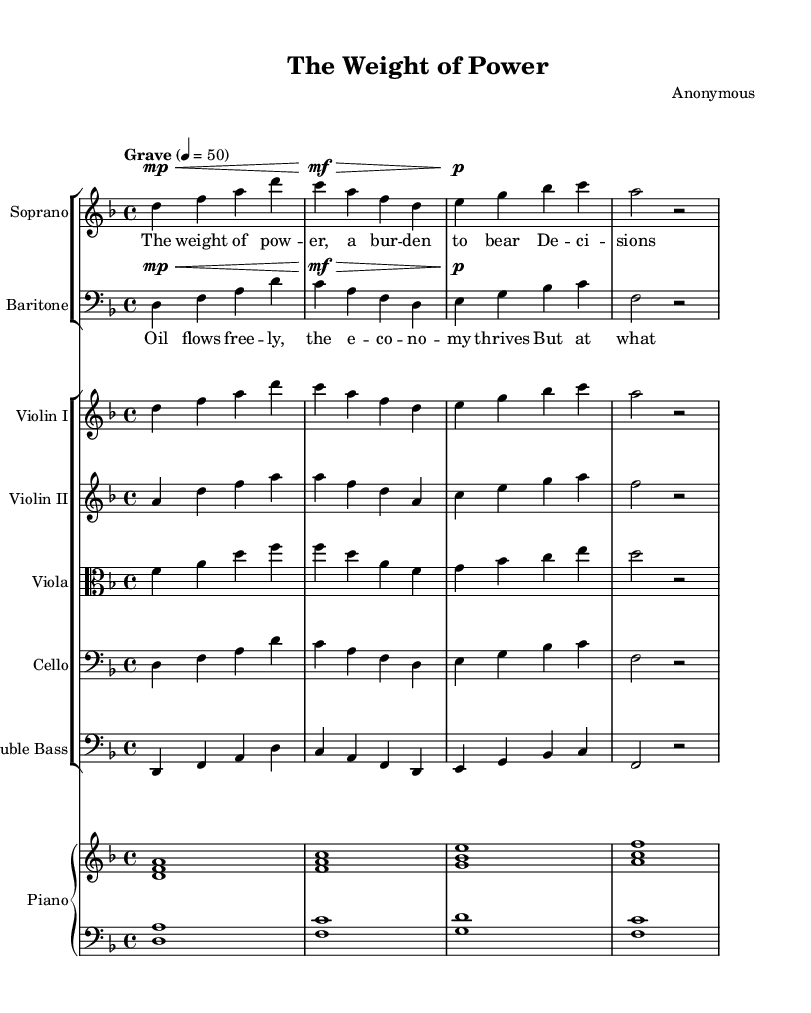What is the key signature of this music? The key signature is indicated at the beginning of the piece, showing two flats, which correspond to the key of D minor.
Answer: D minor What is the time signature of this piece? The time signature is shown at the beginning of the score with a '4/4' notation, indicating four beats per measure.
Answer: 4/4 What is the tempo marking for this opera? The tempo marking is indicated by the word "Grave" followed by a metronome marking of 50 beats per minute, which is a slow tempo.
Answer: Grave How many voices are featured in this piece? The score presents a soprano and a baritone voice, indicated in separate staves. The vocal parts correspond to two distinct characters in the opera.
Answer: Two What is the thematic focus of the lyrics in the soprano's part? The lyrics discuss the burden of leadership and decision-making, as inferred from phrases like "The weight of power" and "Decisions loom."
Answer: Leadership and decision-making What instrument accompanies the soprano and baritone? The piano is the primary accompaniment, as indicated by the presence of the PianoStaff and its two staves for right and left hands that provide harmonic support.
Answer: Piano What is the dynamic marking for the soprano's first phrase? The dynamic marking is indicated as "mp," which stands for mezzo-piano, suggesting a moderately soft volume for the soprano's part.
Answer: mp 